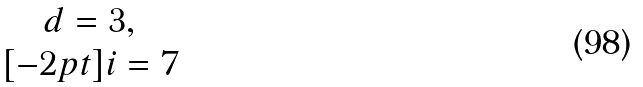<formula> <loc_0><loc_0><loc_500><loc_500>\begin{matrix} d = 3 , \\ [ - 2 p t ] i = 7 \end{matrix}</formula> 